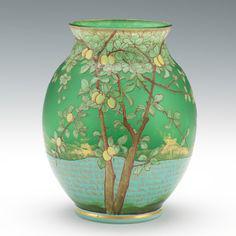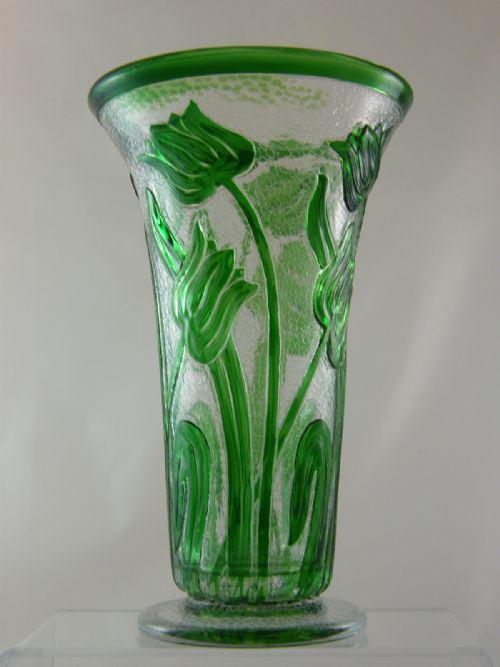The first image is the image on the left, the second image is the image on the right. Considering the images on both sides, is "There is a vase that is predominantly green and a vase that is predominantly yellow." valid? Answer yes or no. No. The first image is the image on the left, the second image is the image on the right. Evaluate the accuracy of this statement regarding the images: "The vases have a floral pattern in both images.". Is it true? Answer yes or no. Yes. 